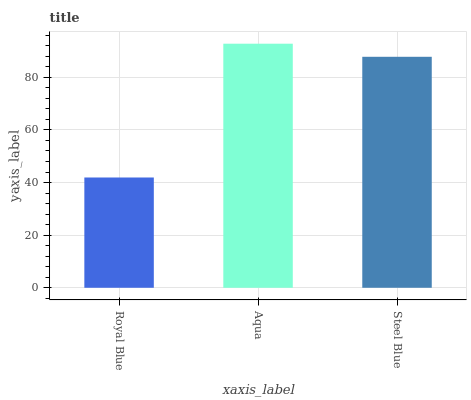Is Royal Blue the minimum?
Answer yes or no. Yes. Is Aqua the maximum?
Answer yes or no. Yes. Is Steel Blue the minimum?
Answer yes or no. No. Is Steel Blue the maximum?
Answer yes or no. No. Is Aqua greater than Steel Blue?
Answer yes or no. Yes. Is Steel Blue less than Aqua?
Answer yes or no. Yes. Is Steel Blue greater than Aqua?
Answer yes or no. No. Is Aqua less than Steel Blue?
Answer yes or no. No. Is Steel Blue the high median?
Answer yes or no. Yes. Is Steel Blue the low median?
Answer yes or no. Yes. Is Aqua the high median?
Answer yes or no. No. Is Aqua the low median?
Answer yes or no. No. 